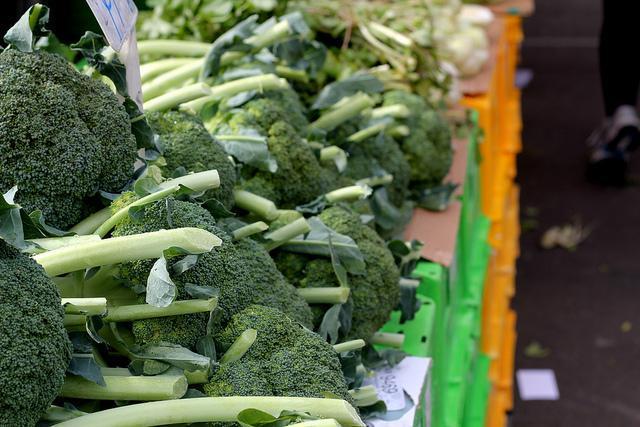How many broccolis are visible?
Give a very brief answer. 9. 